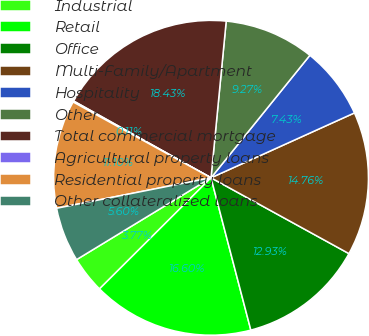Convert chart to OTSL. <chart><loc_0><loc_0><loc_500><loc_500><pie_chart><fcel>Industrial<fcel>Retail<fcel>Office<fcel>Multi-Family/Apartment<fcel>Hospitality<fcel>Other<fcel>Total commercial mortgage<fcel>Agricultural property loans<fcel>Residential property loans<fcel>Other collateralized loans<nl><fcel>3.77%<fcel>16.6%<fcel>12.93%<fcel>14.76%<fcel>7.43%<fcel>9.27%<fcel>18.43%<fcel>0.11%<fcel>11.1%<fcel>5.6%<nl></chart> 